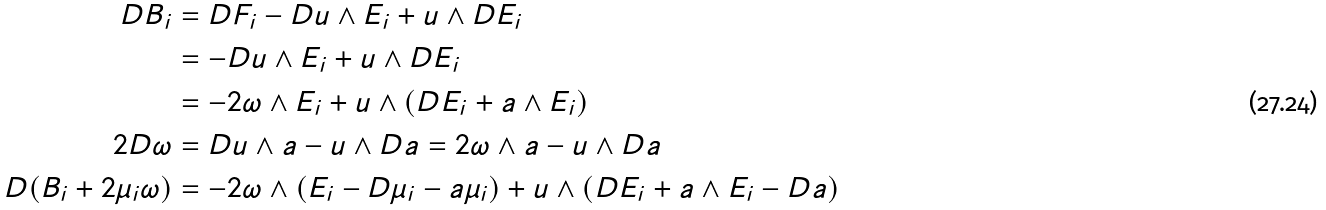<formula> <loc_0><loc_0><loc_500><loc_500>D { B } _ { i } & = D F _ { i } - D u \wedge E _ { i } + u \wedge D E _ { i } \\ & = - D u \wedge E _ { i } + u \wedge D E _ { i } \\ & = - 2 \omega \wedge E _ { i } + u \wedge ( D E _ { i } + a \wedge E _ { i } ) \\ 2 D \omega & = D u \wedge a - u \wedge D a = 2 \omega \wedge a - u \wedge D a \\ D ( B _ { i } + 2 \mu _ { i } \omega ) & = - 2 \omega \wedge ( E _ { i } - D \mu _ { i } - a \mu _ { i } ) + u \wedge ( D E _ { i } + a \wedge E _ { i } - D a ) \\</formula> 